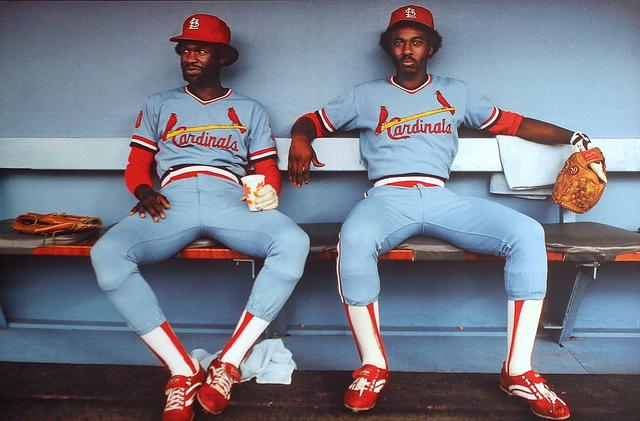Who played for this team?

Choices:
A) mark mcgwire
B) barry bonds
C) alex rodriguez
D) jose canseco mark mcgwire 